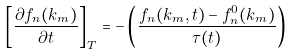<formula> <loc_0><loc_0><loc_500><loc_500>\left [ \frac { \partial f _ { n } ( k _ { m } ) } { \partial t } \right ] _ { T } = - \left ( \frac { f _ { n } ( k _ { m } , t ) - f ^ { 0 } _ { n } ( k _ { m } ) } { \tau ( t ) } \right )</formula> 